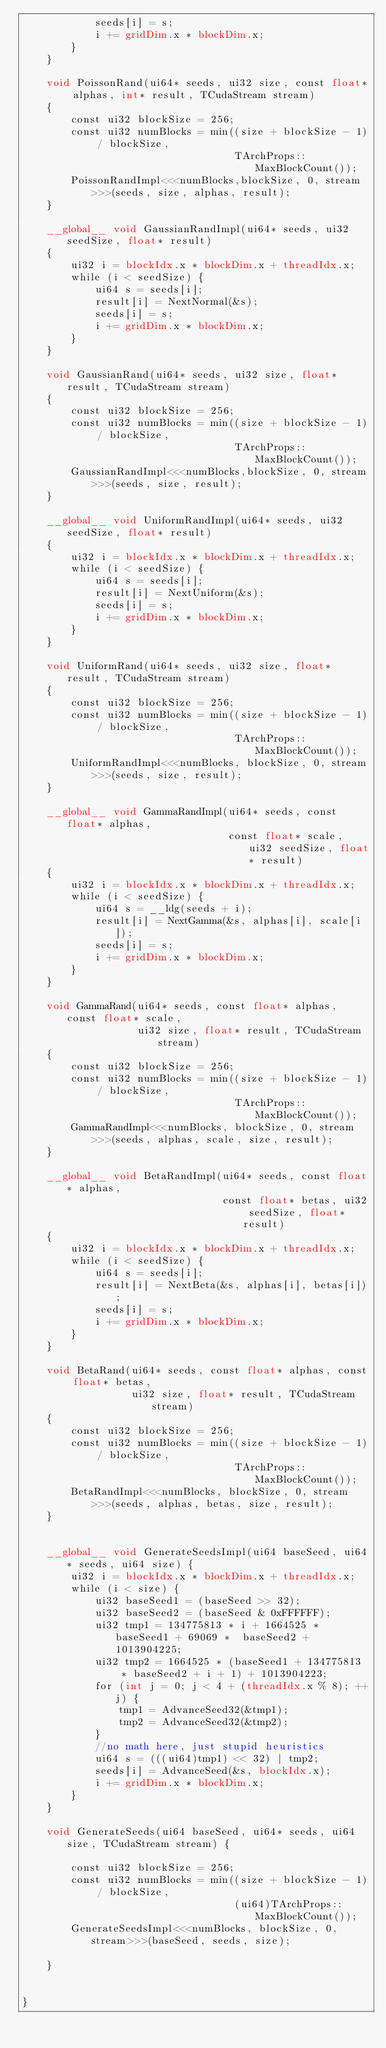<code> <loc_0><loc_0><loc_500><loc_500><_Cuda_>            seeds[i] = s;
            i += gridDim.x * blockDim.x;
        }
    }

    void PoissonRand(ui64* seeds, ui32 size, const float* alphas, int* result, TCudaStream stream)
    {
        const ui32 blockSize = 256;
        const ui32 numBlocks = min((size + blockSize - 1) / blockSize,
                                   TArchProps::MaxBlockCount());
        PoissonRandImpl<<<numBlocks,blockSize, 0, stream>>>(seeds, size, alphas, result);
    }

    __global__ void GaussianRandImpl(ui64* seeds, ui32 seedSize, float* result)
    {
        ui32 i = blockIdx.x * blockDim.x + threadIdx.x;
        while (i < seedSize) {
            ui64 s = seeds[i];
            result[i] = NextNormal(&s);
            seeds[i] = s;
            i += gridDim.x * blockDim.x;
        }
    }

    void GaussianRand(ui64* seeds, ui32 size, float* result, TCudaStream stream)
    {
        const ui32 blockSize = 256;
        const ui32 numBlocks = min((size + blockSize - 1) / blockSize,
                                   TArchProps::MaxBlockCount());
        GaussianRandImpl<<<numBlocks,blockSize, 0, stream>>>(seeds, size, result);
    }

    __global__ void UniformRandImpl(ui64* seeds, ui32 seedSize, float* result)
    {
        ui32 i = blockIdx.x * blockDim.x + threadIdx.x;
        while (i < seedSize) {
            ui64 s = seeds[i];
            result[i] = NextUniform(&s);
            seeds[i] = s;
            i += gridDim.x * blockDim.x;
        }
    }

    void UniformRand(ui64* seeds, ui32 size, float* result, TCudaStream stream)
    {
        const ui32 blockSize = 256;
        const ui32 numBlocks = min((size + blockSize - 1) / blockSize,
                                   TArchProps::MaxBlockCount());
        UniformRandImpl<<<numBlocks, blockSize, 0, stream>>>(seeds, size, result);
    }

    __global__ void GammaRandImpl(ui64* seeds, const float* alphas,
                                  const float* scale, ui32 seedSize, float* result)
    {
        ui32 i = blockIdx.x * blockDim.x + threadIdx.x;
        while (i < seedSize) {
            ui64 s = __ldg(seeds + i);
            result[i] = NextGamma(&s, alphas[i], scale[i]);
            seeds[i] = s;
            i += gridDim.x * blockDim.x;
        }
    }

    void GammaRand(ui64* seeds, const float* alphas, const float* scale,
                   ui32 size, float* result, TCudaStream stream)
    {
        const ui32 blockSize = 256;
        const ui32 numBlocks = min((size + blockSize - 1) / blockSize,
                                   TArchProps::MaxBlockCount());
        GammaRandImpl<<<numBlocks, blockSize, 0, stream>>>(seeds, alphas, scale, size, result);
    }

    __global__ void BetaRandImpl(ui64* seeds, const float* alphas,
                                 const float* betas, ui32 seedSize, float* result)
    {
        ui32 i = blockIdx.x * blockDim.x + threadIdx.x;
        while (i < seedSize) {
            ui64 s = seeds[i];
            result[i] = NextBeta(&s, alphas[i], betas[i]);
            seeds[i] = s;
            i += gridDim.x * blockDim.x;
        }
    }

    void BetaRand(ui64* seeds, const float* alphas, const float* betas,
                  ui32 size, float* result, TCudaStream stream)
    {
        const ui32 blockSize = 256;
        const ui32 numBlocks = min((size + blockSize - 1) / blockSize,
                                   TArchProps::MaxBlockCount());
        BetaRandImpl<<<numBlocks, blockSize, 0, stream>>>(seeds, alphas, betas, size, result);
    }


    __global__ void GenerateSeedsImpl(ui64 baseSeed, ui64* seeds, ui64 size) {
        ui32 i = blockIdx.x * blockDim.x + threadIdx.x;
        while (i < size) {
            ui32 baseSeed1 = (baseSeed >> 32);
            ui32 baseSeed2 = (baseSeed & 0xFFFFFF);
            ui32 tmp1 = 134775813 * i + 1664525 * baseSeed1 + 69069 *  baseSeed2 + 1013904225;
            ui32 tmp2 = 1664525 * (baseSeed1 + 134775813  * baseSeed2 + i + 1) + 1013904223;
            for (int j = 0; j < 4 + (threadIdx.x % 8); ++j) {
                tmp1 = AdvanceSeed32(&tmp1);
                tmp2 = AdvanceSeed32(&tmp2);
            }
            //no math here, just stupid heuristics
            ui64 s = (((ui64)tmp1) << 32) | tmp2;
            seeds[i] = AdvanceSeed(&s, blockIdx.x);
            i += gridDim.x * blockDim.x;
        }
    }

    void GenerateSeeds(ui64 baseSeed, ui64* seeds, ui64 size, TCudaStream stream) {

        const ui32 blockSize = 256;
        const ui32 numBlocks = min((size + blockSize - 1) / blockSize,
                                   (ui64)TArchProps::MaxBlockCount());
        GenerateSeedsImpl<<<numBlocks, blockSize, 0, stream>>>(baseSeed, seeds, size);

    }


}
</code> 